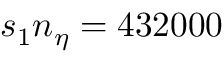<formula> <loc_0><loc_0><loc_500><loc_500>s _ { 1 } n _ { \eta } = 4 3 2 0 0 0</formula> 